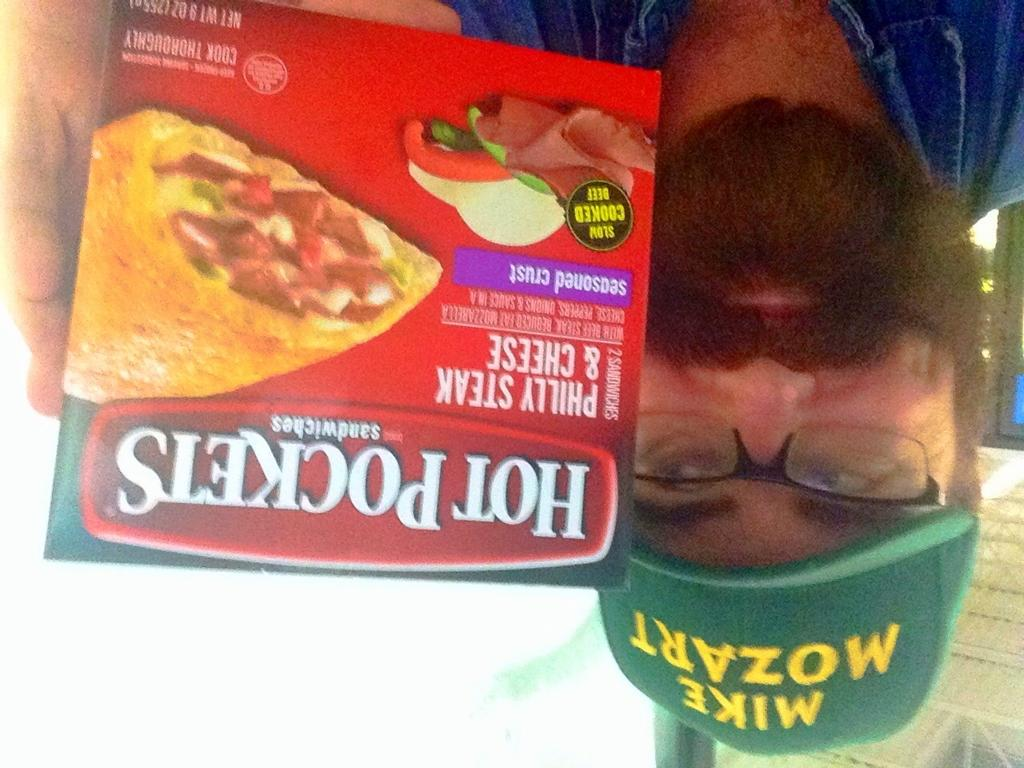What is the main subject of the image? There is a person in the image. What is the person holding in the image? The person is holding a food box. Can you describe the background of the image? There are objects in the background of the image. What type of zinc is visible in the image? There is no zinc present in the image. How many steps can be seen in the image? There is no reference to steps in the image. 